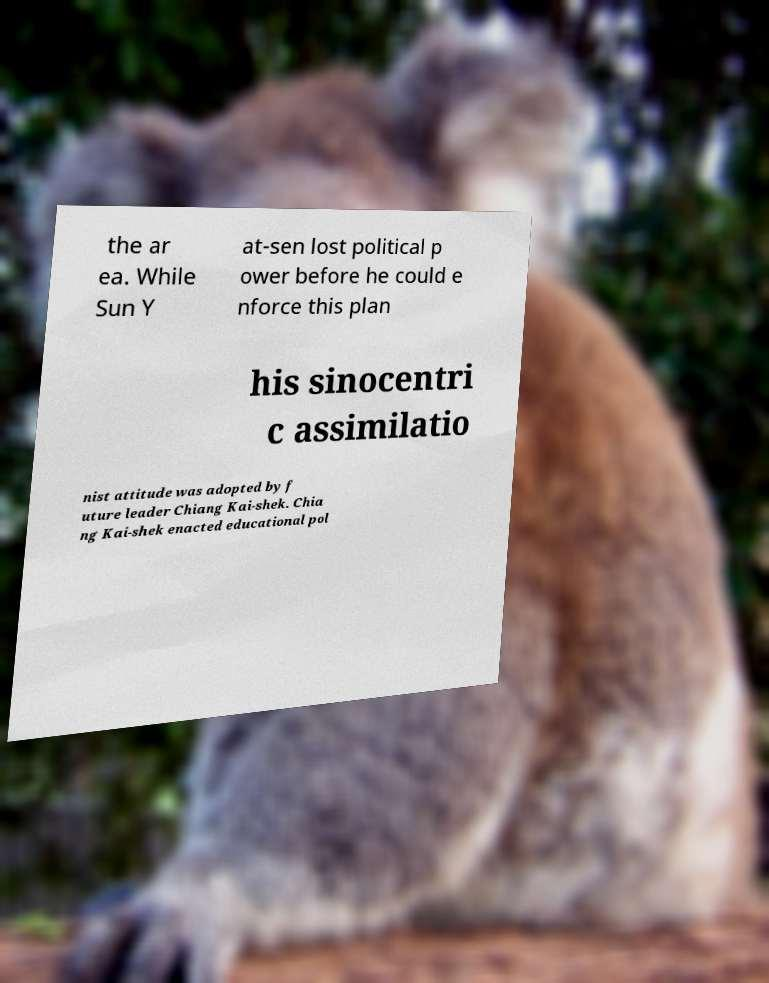Could you assist in decoding the text presented in this image and type it out clearly? the ar ea. While Sun Y at-sen lost political p ower before he could e nforce this plan his sinocentri c assimilatio nist attitude was adopted by f uture leader Chiang Kai-shek. Chia ng Kai-shek enacted educational pol 